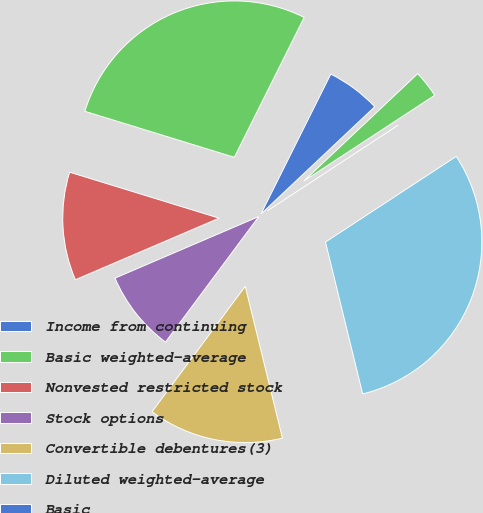Convert chart. <chart><loc_0><loc_0><loc_500><loc_500><pie_chart><fcel>Income from continuing<fcel>Basic weighted-average<fcel>Nonvested restricted stock<fcel>Stock options<fcel>Convertible debentures(3)<fcel>Diluted weighted-average<fcel>Basic<fcel>Diluted<nl><fcel>5.6%<fcel>27.62%<fcel>11.19%<fcel>8.39%<fcel>13.99%<fcel>30.41%<fcel>0.0%<fcel>2.8%<nl></chart> 